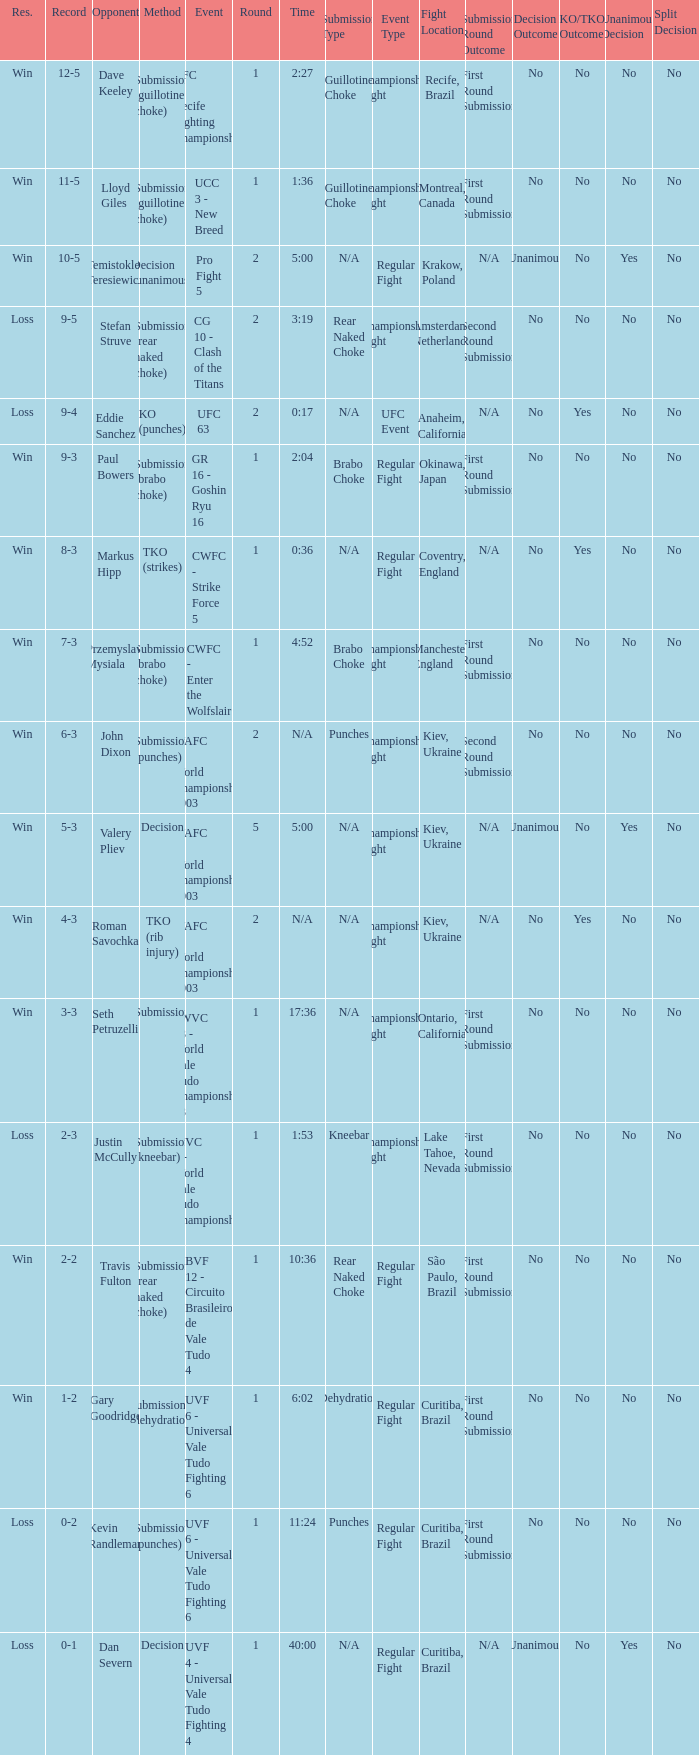What opponent uses the method of decision and a 5-3 record? Valery Pliev. 